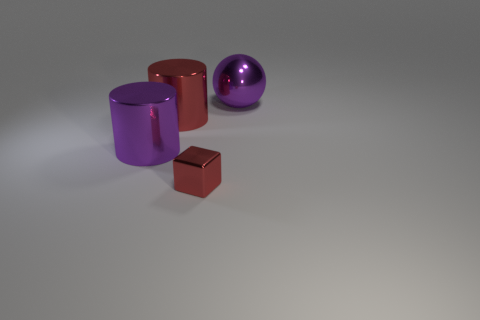Is there anything else that is the same size as the block?
Offer a terse response. No. Is the large cylinder that is to the right of the purple metallic cylinder made of the same material as the purple ball behind the big purple shiny cylinder?
Give a very brief answer. Yes. What color is the other cylinder that is the same size as the red metal cylinder?
Offer a terse response. Purple. There is a metal cylinder behind the large purple object that is left of the big purple thing to the right of the big purple metallic cylinder; how big is it?
Offer a terse response. Large. There is a object that is on the right side of the big red cylinder and behind the small red block; what is its color?
Your answer should be very brief. Purple. What size is the purple thing that is in front of the large shiny sphere?
Provide a short and direct response. Large. What number of big purple things have the same material as the red cylinder?
Offer a very short reply. 2. There is a thing that is the same color as the small cube; what is its shape?
Provide a succinct answer. Cylinder. There is a purple metal thing that is on the left side of the tiny metal object; does it have the same shape as the big red metal object?
Ensure brevity in your answer.  Yes. The ball that is the same material as the block is what color?
Your response must be concise. Purple. 